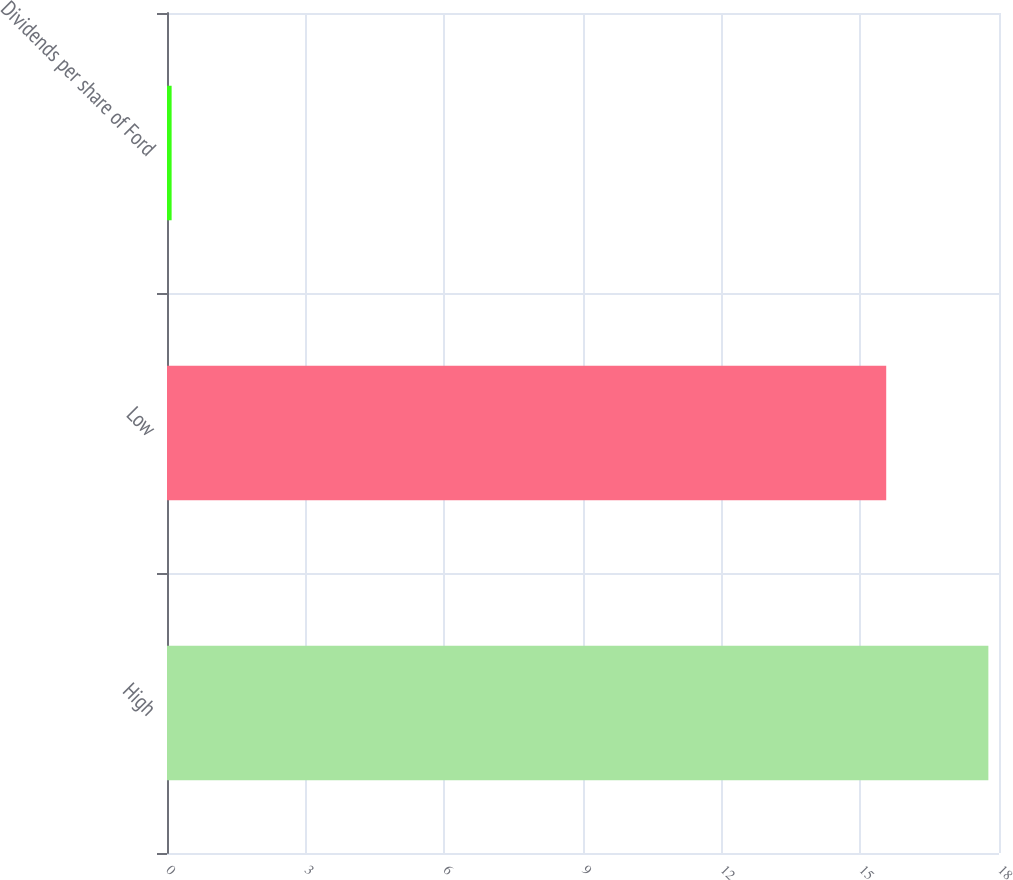Convert chart to OTSL. <chart><loc_0><loc_0><loc_500><loc_500><bar_chart><fcel>High<fcel>Low<fcel>Dividends per share of Ford<nl><fcel>17.77<fcel>15.56<fcel>0.1<nl></chart> 